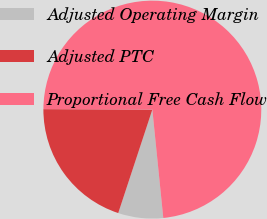Convert chart. <chart><loc_0><loc_0><loc_500><loc_500><pie_chart><fcel>Adjusted Operating Margin<fcel>Adjusted PTC<fcel>Proportional Free Cash Flow<nl><fcel>6.67%<fcel>20.0%<fcel>73.33%<nl></chart> 